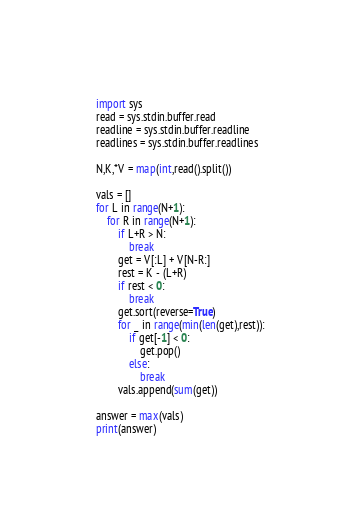Convert code to text. <code><loc_0><loc_0><loc_500><loc_500><_Python_>import sys
read = sys.stdin.buffer.read
readline = sys.stdin.buffer.readline
readlines = sys.stdin.buffer.readlines

N,K,*V = map(int,read().split())

vals = []
for L in range(N+1):
    for R in range(N+1):
        if L+R > N:
            break
        get = V[:L] + V[N-R:]
        rest = K - (L+R)
        if rest < 0:
            break
        get.sort(reverse=True)
        for _ in range(min(len(get),rest)):
            if get[-1] < 0:
                get.pop()
            else:
                break
        vals.append(sum(get))

answer = max(vals)
print(answer)</code> 